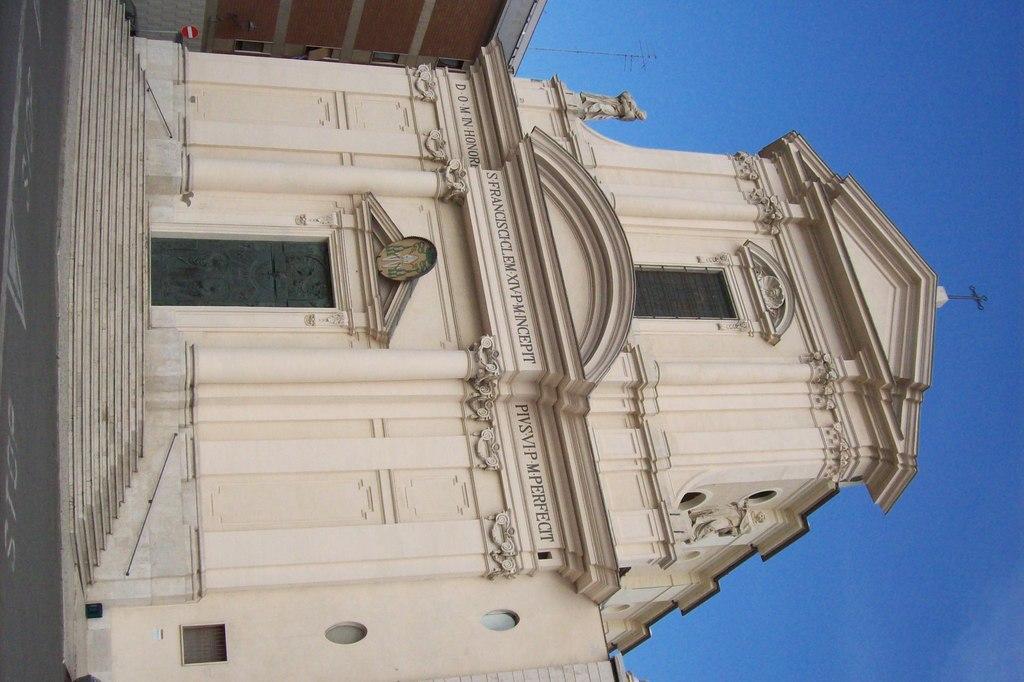Could you give a brief overview of what you see in this image? In the center of the image, we can see a building and there is a board and we can see some text on the wall and there are stairs. At the top, there is sky and we can see a pole. At the bottom, there is a road. 